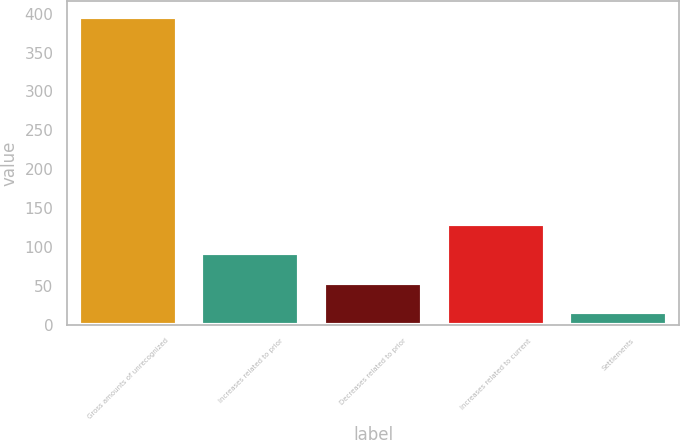Convert chart to OTSL. <chart><loc_0><loc_0><loc_500><loc_500><bar_chart><fcel>Gross amounts of unrecognized<fcel>Increases related to prior<fcel>Decreases related to prior<fcel>Increases related to current<fcel>Settlements<nl><fcel>396<fcel>92<fcel>54<fcel>130<fcel>16<nl></chart> 